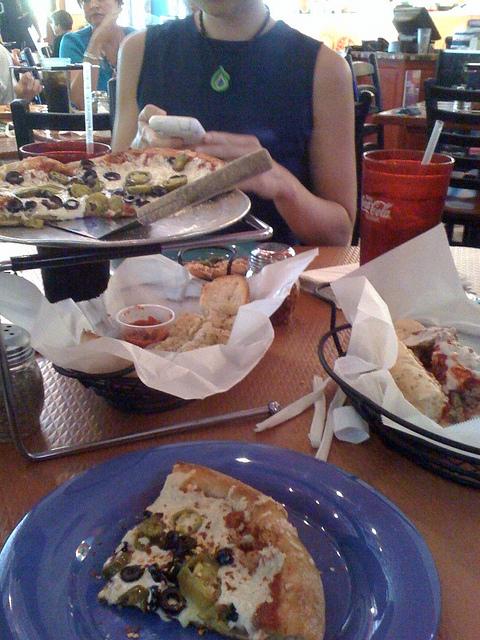What is in the thing with coke? The object protruding from the cola beverage appears to be a straw, which is a cylindrical tube commonly used to transport liquids from a container to the mouth, allowing for convenient drinking without the need to lift the container. 